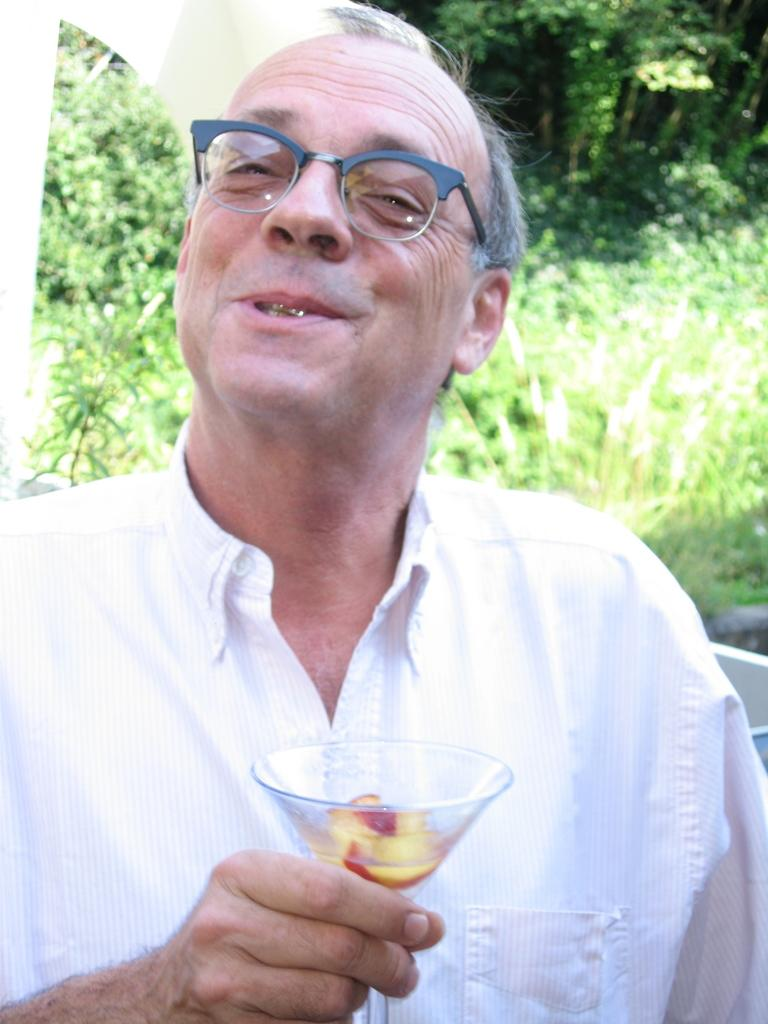Who is present in the image? There is a person in the image. What is the person holding in the image? The person is holding a glass. What is the person wearing in the image? The person is wearing a white dress. What can be seen in the background of the image? There are trees visible in the background of the image. What type of stove can be seen in the image? There is no stove present in the image. What holiday is the person celebrating in the image? The image does not provide any information about a holiday being celebrated. 